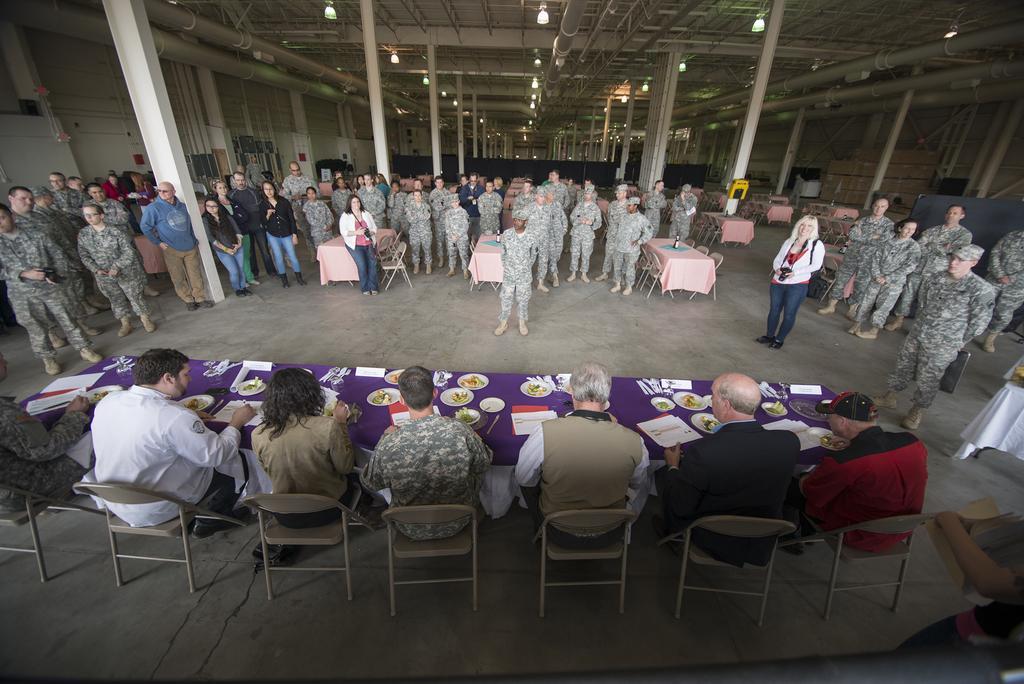In one or two sentences, can you explain what this image depicts? people are seated on the chairs. in front of them there is a table on which there are paper, plates and food. at the back there are people standing wearing uniform. there are tables and chairs in between. on the top there are lights. 